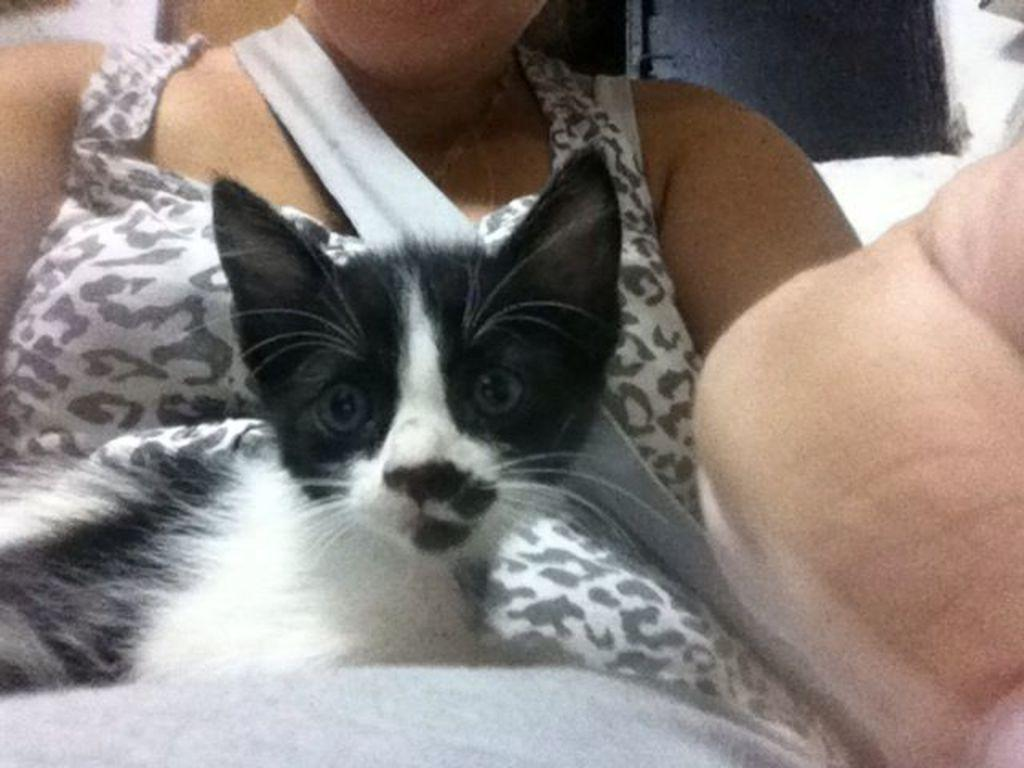What is the main subject of the image? There is a person in the image. What is the person holding in the image? The person is holding a cat. Can you describe the appearance of the cat? The cat is black and white in color. What is the color scheme of the background in the image? The background of the image is in black and white. What type of flavor can be tasted in the sleet depicted in the image? There is no sleet present in the image, and therefore no flavor can be tasted. How low is the cat sitting in the image? The image does not provide information about the cat's sitting position, so it cannot be determined how low it is sitting. 